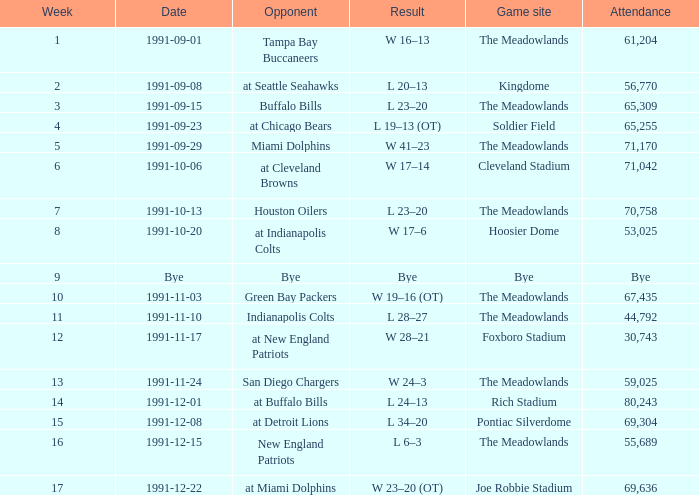Which adversary was played on 1991-10-13? Houston Oilers. Could you parse the entire table? {'header': ['Week', 'Date', 'Opponent', 'Result', 'Game site', 'Attendance'], 'rows': [['1', '1991-09-01', 'Tampa Bay Buccaneers', 'W 16–13', 'The Meadowlands', '61,204'], ['2', '1991-09-08', 'at Seattle Seahawks', 'L 20–13', 'Kingdome', '56,770'], ['3', '1991-09-15', 'Buffalo Bills', 'L 23–20', 'The Meadowlands', '65,309'], ['4', '1991-09-23', 'at Chicago Bears', 'L 19–13 (OT)', 'Soldier Field', '65,255'], ['5', '1991-09-29', 'Miami Dolphins', 'W 41–23', 'The Meadowlands', '71,170'], ['6', '1991-10-06', 'at Cleveland Browns', 'W 17–14', 'Cleveland Stadium', '71,042'], ['7', '1991-10-13', 'Houston Oilers', 'L 23–20', 'The Meadowlands', '70,758'], ['8', '1991-10-20', 'at Indianapolis Colts', 'W 17–6', 'Hoosier Dome', '53,025'], ['9', 'Bye', 'Bye', 'Bye', 'Bye', 'Bye'], ['10', '1991-11-03', 'Green Bay Packers', 'W 19–16 (OT)', 'The Meadowlands', '67,435'], ['11', '1991-11-10', 'Indianapolis Colts', 'L 28–27', 'The Meadowlands', '44,792'], ['12', '1991-11-17', 'at New England Patriots', 'W 28–21', 'Foxboro Stadium', '30,743'], ['13', '1991-11-24', 'San Diego Chargers', 'W 24–3', 'The Meadowlands', '59,025'], ['14', '1991-12-01', 'at Buffalo Bills', 'L 24–13', 'Rich Stadium', '80,243'], ['15', '1991-12-08', 'at Detroit Lions', 'L 34–20', 'Pontiac Silverdome', '69,304'], ['16', '1991-12-15', 'New England Patriots', 'L 6–3', 'The Meadowlands', '55,689'], ['17', '1991-12-22', 'at Miami Dolphins', 'W 23–20 (OT)', 'Joe Robbie Stadium', '69,636']]} 